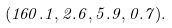<formula> <loc_0><loc_0><loc_500><loc_500>( 1 6 0 . 1 , 2 . 6 , 5 . 9 , 0 . 7 ) .</formula> 